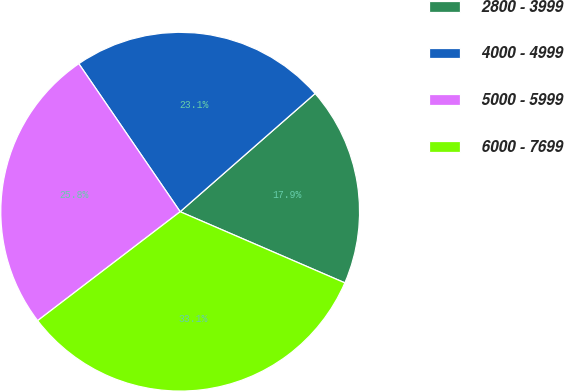<chart> <loc_0><loc_0><loc_500><loc_500><pie_chart><fcel>2800 - 3999<fcel>4000 - 4999<fcel>5000 - 5999<fcel>6000 - 7699<nl><fcel>17.94%<fcel>23.11%<fcel>25.83%<fcel>33.12%<nl></chart> 